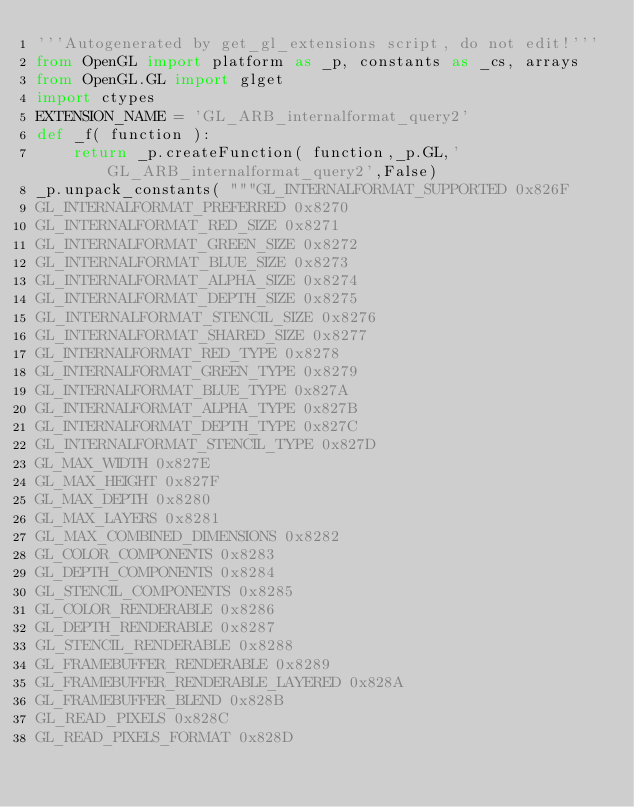Convert code to text. <code><loc_0><loc_0><loc_500><loc_500><_Python_>'''Autogenerated by get_gl_extensions script, do not edit!'''
from OpenGL import platform as _p, constants as _cs, arrays
from OpenGL.GL import glget
import ctypes
EXTENSION_NAME = 'GL_ARB_internalformat_query2'
def _f( function ):
    return _p.createFunction( function,_p.GL,'GL_ARB_internalformat_query2',False)
_p.unpack_constants( """GL_INTERNALFORMAT_SUPPORTED 0x826F
GL_INTERNALFORMAT_PREFERRED 0x8270
GL_INTERNALFORMAT_RED_SIZE 0x8271
GL_INTERNALFORMAT_GREEN_SIZE 0x8272
GL_INTERNALFORMAT_BLUE_SIZE 0x8273
GL_INTERNALFORMAT_ALPHA_SIZE 0x8274
GL_INTERNALFORMAT_DEPTH_SIZE 0x8275
GL_INTERNALFORMAT_STENCIL_SIZE 0x8276
GL_INTERNALFORMAT_SHARED_SIZE 0x8277
GL_INTERNALFORMAT_RED_TYPE 0x8278
GL_INTERNALFORMAT_GREEN_TYPE 0x8279
GL_INTERNALFORMAT_BLUE_TYPE 0x827A
GL_INTERNALFORMAT_ALPHA_TYPE 0x827B
GL_INTERNALFORMAT_DEPTH_TYPE 0x827C
GL_INTERNALFORMAT_STENCIL_TYPE 0x827D
GL_MAX_WIDTH 0x827E
GL_MAX_HEIGHT 0x827F
GL_MAX_DEPTH 0x8280
GL_MAX_LAYERS 0x8281
GL_MAX_COMBINED_DIMENSIONS 0x8282
GL_COLOR_COMPONENTS 0x8283
GL_DEPTH_COMPONENTS 0x8284
GL_STENCIL_COMPONENTS 0x8285
GL_COLOR_RENDERABLE 0x8286
GL_DEPTH_RENDERABLE 0x8287
GL_STENCIL_RENDERABLE 0x8288
GL_FRAMEBUFFER_RENDERABLE 0x8289
GL_FRAMEBUFFER_RENDERABLE_LAYERED 0x828A
GL_FRAMEBUFFER_BLEND 0x828B
GL_READ_PIXELS 0x828C
GL_READ_PIXELS_FORMAT 0x828D</code> 